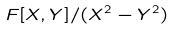Convert formula to latex. <formula><loc_0><loc_0><loc_500><loc_500>F [ X , Y ] / ( X ^ { 2 } - Y ^ { 2 } )</formula> 